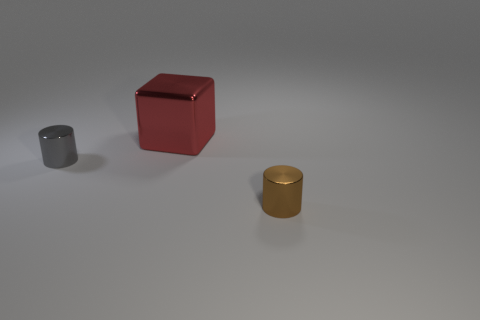The metal block is what color?
Make the answer very short. Red. How many other objects are the same shape as the red shiny thing?
Your answer should be very brief. 0. Is the number of tiny objects that are in front of the brown thing the same as the number of brown shiny cylinders that are in front of the gray shiny object?
Offer a terse response. No. What material is the brown object in front of the large metallic thing?
Offer a very short reply. Metal. Is the number of small metallic cylinders left of the red cube greater than the number of purple shiny blocks?
Offer a very short reply. Yes. Are there any small gray shiny things behind the cylinder that is in front of the tiny metal object that is on the left side of the large shiny cube?
Your answer should be very brief. Yes. There is a red metal thing; are there any shiny cylinders in front of it?
Ensure brevity in your answer.  Yes. There is a brown cylinder that is the same material as the big red object; what is its size?
Keep it short and to the point. Small. There is a red shiny cube that is behind the tiny cylinder that is in front of the metal cylinder that is left of the big red metal thing; how big is it?
Offer a very short reply. Large. There is a red metal block that is left of the small brown object; what size is it?
Ensure brevity in your answer.  Large. 